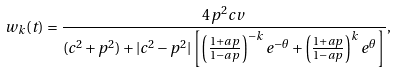<formula> <loc_0><loc_0><loc_500><loc_500>w _ { k } ( t ) = \frac { 4 p ^ { 2 } c v } { ( c ^ { 2 } + p ^ { 2 } ) + | c ^ { 2 } - p ^ { 2 } | \left [ \left ( \frac { 1 + a p } { 1 - a p } \right ) ^ { - k } e ^ { - \theta } + \left ( \frac { 1 + a p } { 1 - a p } \right ) ^ { k } e ^ { \theta } \right ] } ,</formula> 